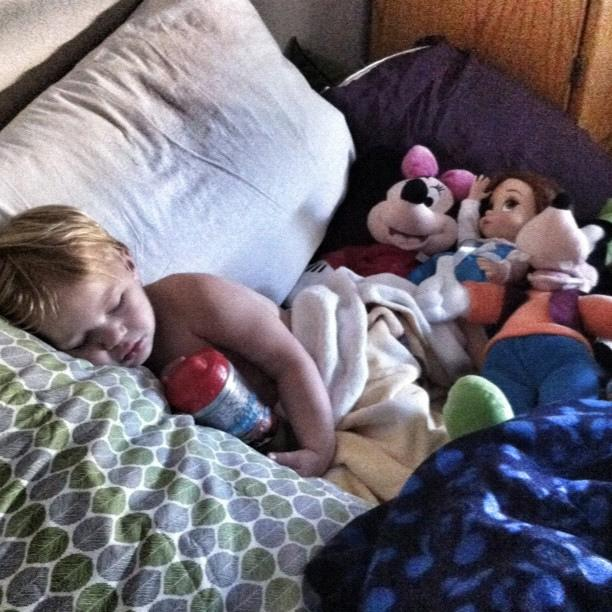In which one of these cities can you meet the characters shown here? orlando 